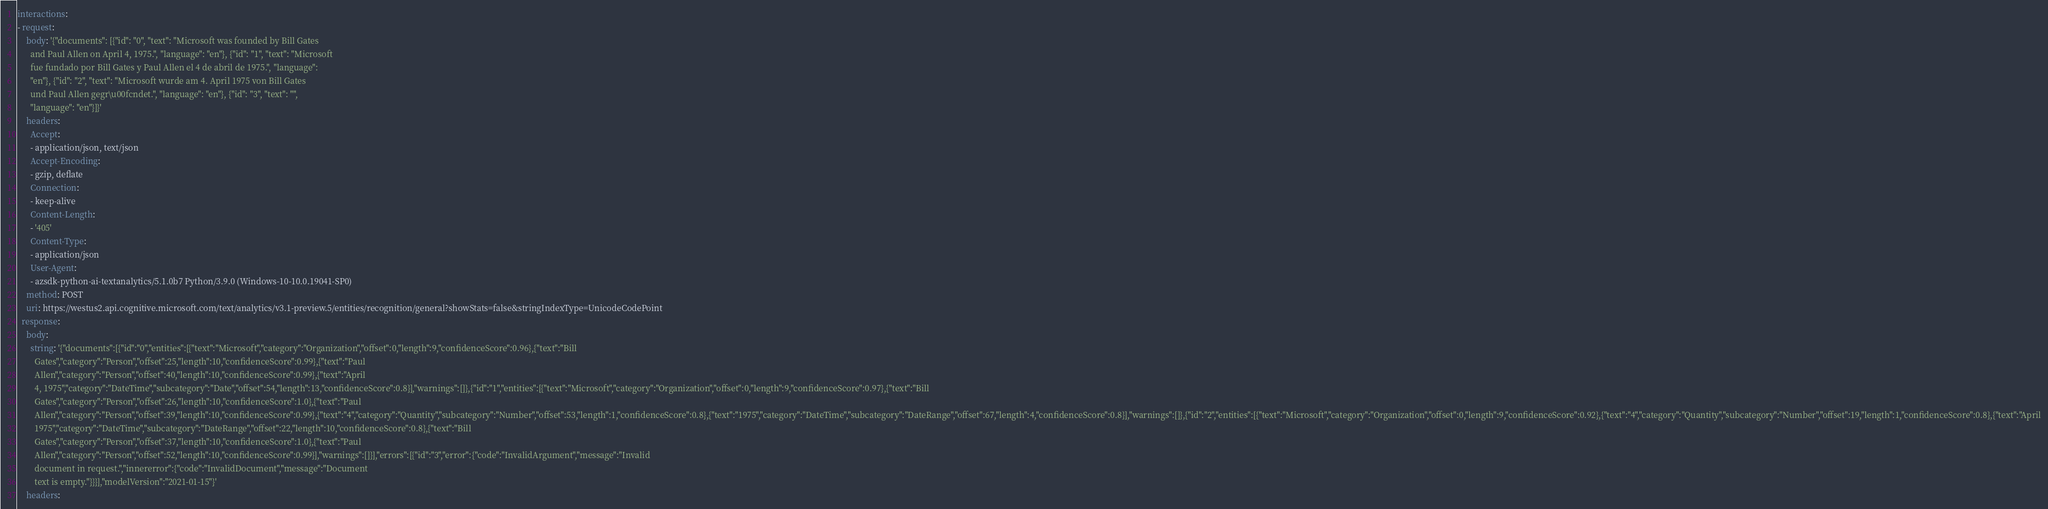Convert code to text. <code><loc_0><loc_0><loc_500><loc_500><_YAML_>interactions:
- request:
    body: '{"documents": [{"id": "0", "text": "Microsoft was founded by Bill Gates
      and Paul Allen on April 4, 1975.", "language": "en"}, {"id": "1", "text": "Microsoft
      fue fundado por Bill Gates y Paul Allen el 4 de abril de 1975.", "language":
      "en"}, {"id": "2", "text": "Microsoft wurde am 4. April 1975 von Bill Gates
      und Paul Allen gegr\u00fcndet.", "language": "en"}, {"id": "3", "text": "",
      "language": "en"}]}'
    headers:
      Accept:
      - application/json, text/json
      Accept-Encoding:
      - gzip, deflate
      Connection:
      - keep-alive
      Content-Length:
      - '405'
      Content-Type:
      - application/json
      User-Agent:
      - azsdk-python-ai-textanalytics/5.1.0b7 Python/3.9.0 (Windows-10-10.0.19041-SP0)
    method: POST
    uri: https://westus2.api.cognitive.microsoft.com/text/analytics/v3.1-preview.5/entities/recognition/general?showStats=false&stringIndexType=UnicodeCodePoint
  response:
    body:
      string: '{"documents":[{"id":"0","entities":[{"text":"Microsoft","category":"Organization","offset":0,"length":9,"confidenceScore":0.96},{"text":"Bill
        Gates","category":"Person","offset":25,"length":10,"confidenceScore":0.99},{"text":"Paul
        Allen","category":"Person","offset":40,"length":10,"confidenceScore":0.99},{"text":"April
        4, 1975","category":"DateTime","subcategory":"Date","offset":54,"length":13,"confidenceScore":0.8}],"warnings":[]},{"id":"1","entities":[{"text":"Microsoft","category":"Organization","offset":0,"length":9,"confidenceScore":0.97},{"text":"Bill
        Gates","category":"Person","offset":26,"length":10,"confidenceScore":1.0},{"text":"Paul
        Allen","category":"Person","offset":39,"length":10,"confidenceScore":0.99},{"text":"4","category":"Quantity","subcategory":"Number","offset":53,"length":1,"confidenceScore":0.8},{"text":"1975","category":"DateTime","subcategory":"DateRange","offset":67,"length":4,"confidenceScore":0.8}],"warnings":[]},{"id":"2","entities":[{"text":"Microsoft","category":"Organization","offset":0,"length":9,"confidenceScore":0.92},{"text":"4","category":"Quantity","subcategory":"Number","offset":19,"length":1,"confidenceScore":0.8},{"text":"April
        1975","category":"DateTime","subcategory":"DateRange","offset":22,"length":10,"confidenceScore":0.8},{"text":"Bill
        Gates","category":"Person","offset":37,"length":10,"confidenceScore":1.0},{"text":"Paul
        Allen","category":"Person","offset":52,"length":10,"confidenceScore":0.99}],"warnings":[]}],"errors":[{"id":"3","error":{"code":"InvalidArgument","message":"Invalid
        document in request.","innererror":{"code":"InvalidDocument","message":"Document
        text is empty."}}}],"modelVersion":"2021-01-15"}'
    headers:</code> 